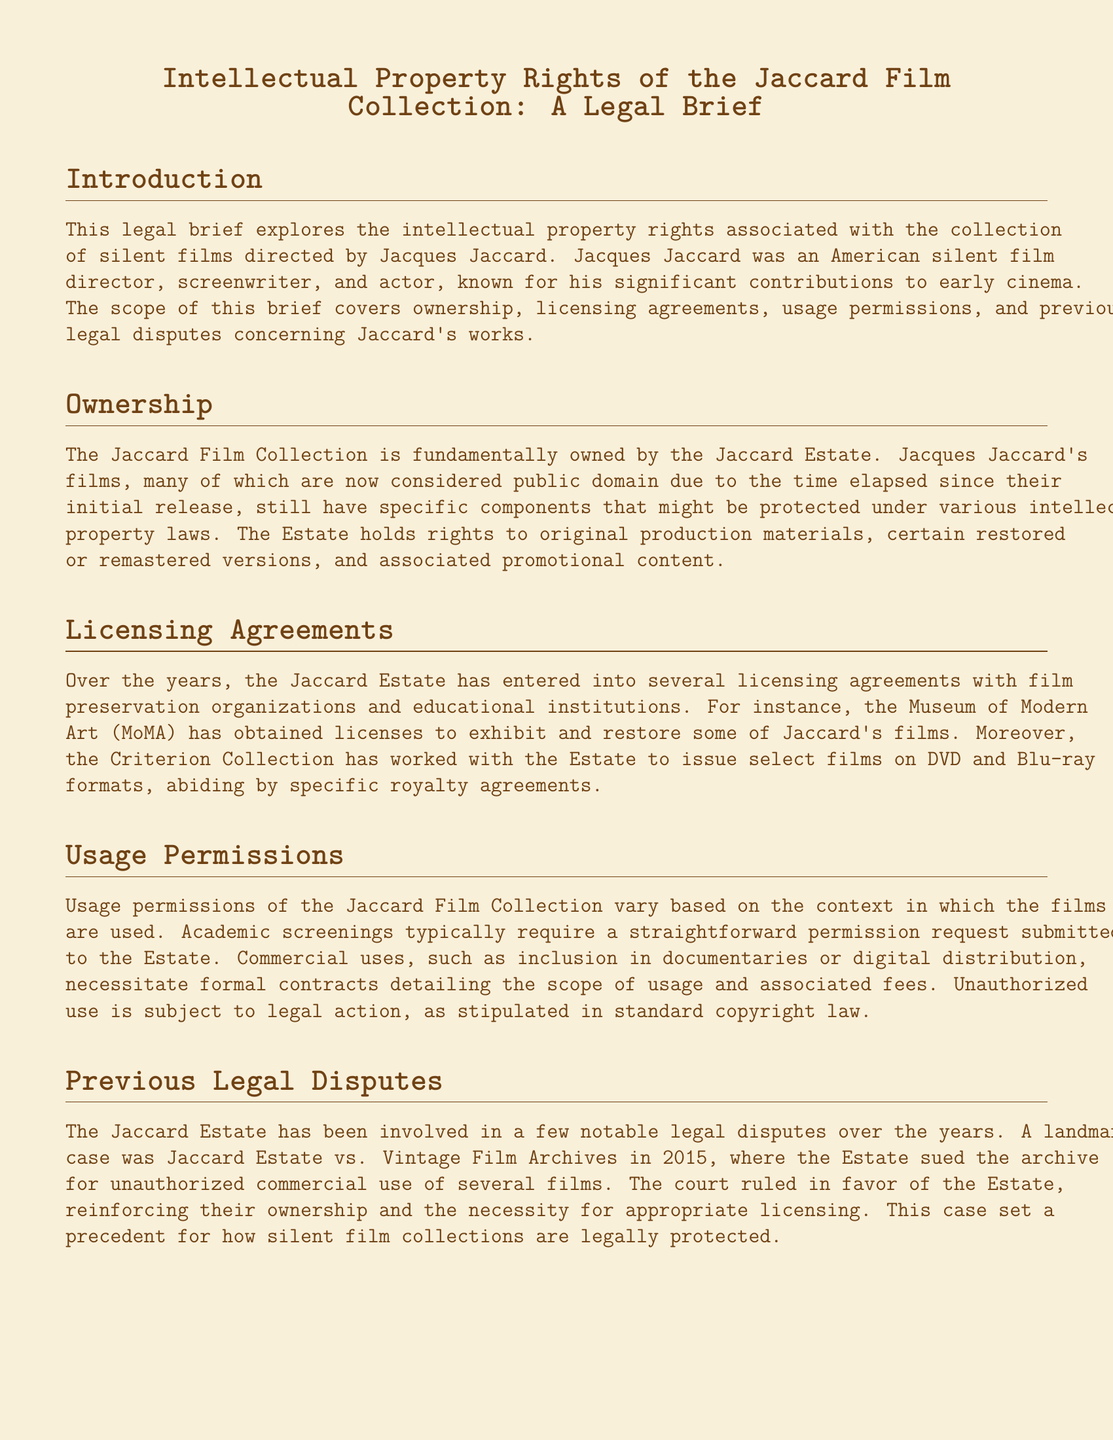what films does the Jaccard Estate hold rights to? The Jaccard Estate holds rights to original production materials, certain restored or remastered versions, and associated promotional content.
Answer: original production materials, certain restored or remastered versions, and associated promotional content which institution obtained licenses to exhibit Jaccard's films? The Museum of Modern Art (MoMA) obtained licenses to exhibit and restore some of Jaccard's films.
Answer: Museum of Modern Art (MoMA) what year did the landmark case involving the Jaccard Estate occur? The landmark case Jaccard Estate vs. Vintage Film Archives occurred in 2015.
Answer: 2015 what type of screenings require a straightforward permission request to the Estate? Academic screenings require a straightforward permission request submitted to the Estate.
Answer: Academic screenings who worked with the Estate to issue select films on DVD? The Criterion Collection worked with the Estate to issue select films on DVD.
Answer: Criterion Collection what happens to unauthorized use of the films? Unauthorized use is subject to legal action, as stipulated in standard copyright law.
Answer: legal action what requires formal contracts detailing the scope of usage? Commercial uses, such as inclusion in documentaries or digital distribution, necessitate formal contracts detailing the scope of usage and associated fees.
Answer: Commercial uses what is a key aspect of the Jaccard Estate's control over the films? The Jaccard Estate maintains significant control over specific versions and related materials.
Answer: specific versions and related materials 